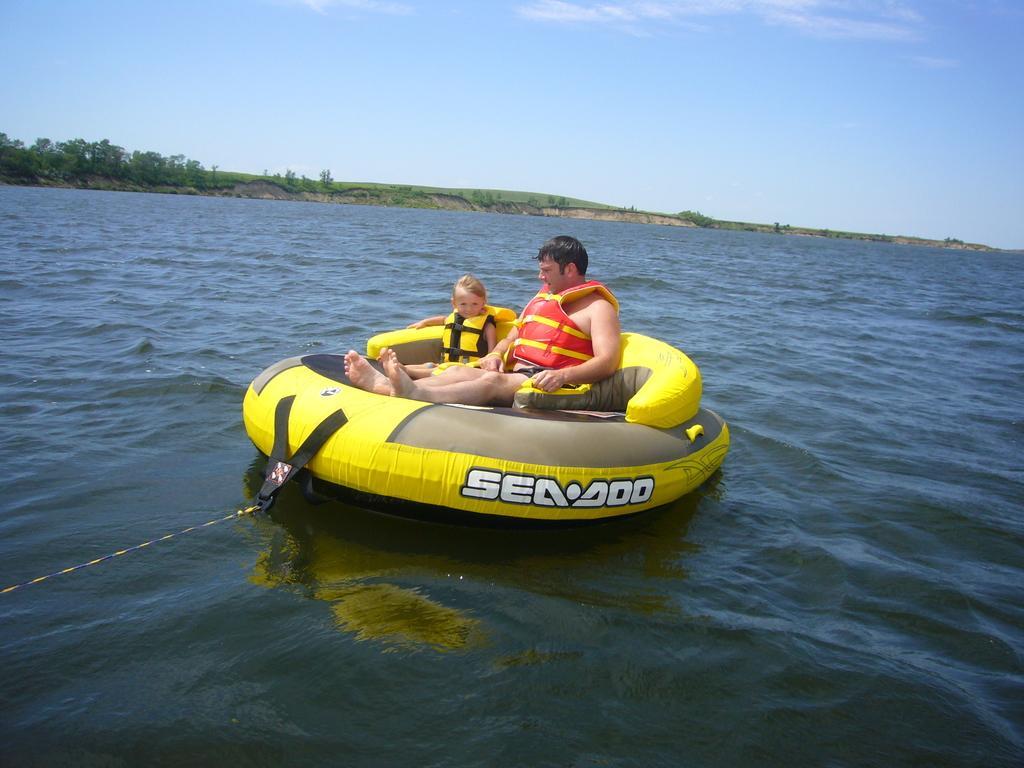In one or two sentences, can you explain what this image depicts? In this image I can see two persons sitting in a tube and the tube is on the water, and the tube is in yellow color. The persons are wearing orange and yellow color jacket, background I can see trees in green color and the sky is in blue and white color. 